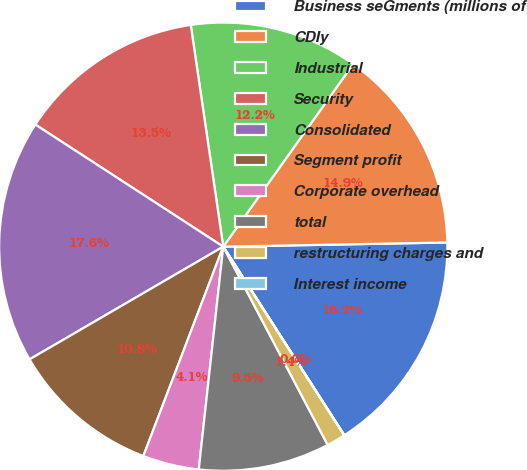<chart> <loc_0><loc_0><loc_500><loc_500><pie_chart><fcel>Business seGments (millions of<fcel>CDIy<fcel>Industrial<fcel>Security<fcel>Consolidated<fcel>Segment profit<fcel>Corporate overhead<fcel>total<fcel>restructuring charges and<fcel>Interest income<nl><fcel>16.21%<fcel>14.86%<fcel>12.16%<fcel>13.51%<fcel>17.56%<fcel>10.81%<fcel>4.06%<fcel>9.46%<fcel>1.36%<fcel>0.01%<nl></chart> 